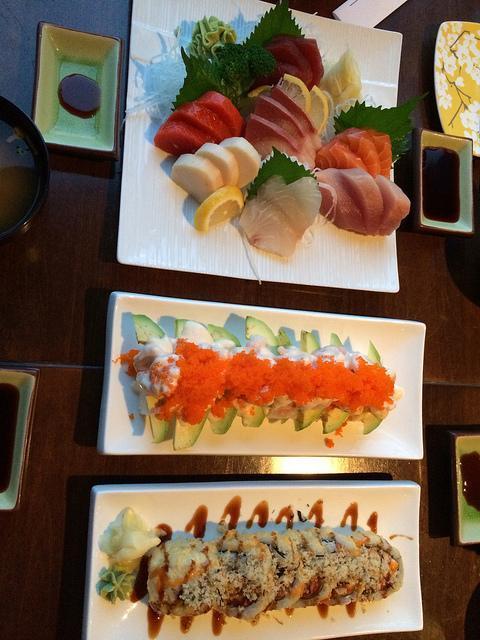How many bowls are there?
Give a very brief answer. 3. How many zebras can you count in this picture?
Give a very brief answer. 0. 